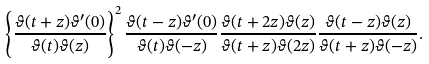<formula> <loc_0><loc_0><loc_500><loc_500>\left \{ \frac { \vartheta ( t + z ) \vartheta ^ { \prime } ( 0 ) } { \vartheta ( t ) \vartheta ( z ) } \right \} ^ { 2 } \frac { \vartheta ( t - z ) \vartheta ^ { \prime } ( 0 ) } { \vartheta ( t ) \vartheta ( - z ) } \frac { \vartheta ( t + 2 z ) \vartheta ( z ) } { \vartheta ( t + z ) \vartheta ( 2 z ) } \frac { \vartheta ( t - z ) \vartheta ( z ) } { \vartheta ( t + z ) \vartheta ( - z ) } .</formula> 